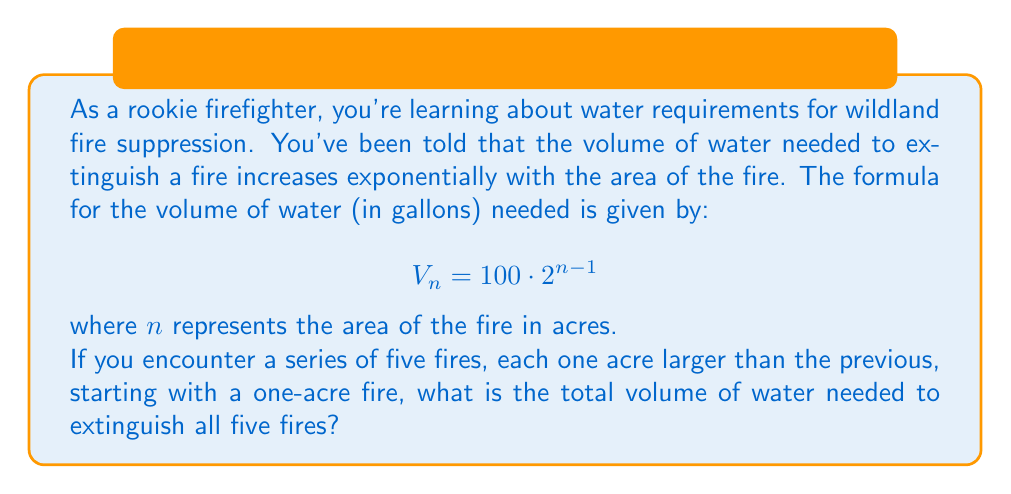Can you answer this question? Let's approach this step-by-step:

1) We need to find the sum of the volumes for fires of 1, 2, 3, 4, and 5 acres.

2) Let's calculate the volume for each fire size:

   For 1 acre: $V_1 = 100 \cdot 2^{1-1} = 100 \cdot 1 = 100$ gallons
   For 2 acres: $V_2 = 100 \cdot 2^{2-1} = 100 \cdot 2 = 200$ gallons
   For 3 acres: $V_3 = 100 \cdot 2^{3-1} = 100 \cdot 4 = 400$ gallons
   For 4 acres: $V_4 = 100 \cdot 2^{4-1} = 100 \cdot 8 = 800$ gallons
   For 5 acres: $V_5 = 100 \cdot 2^{5-1} = 100 \cdot 16 = 1600$ gallons

3) Now, we need to sum these volumes:

   $$\text{Total Volume} = V_1 + V_2 + V_3 + V_4 + V_5$$
   $$= 100 + 200 + 400 + 800 + 1600$$

4) Adding these up:

   $$\text{Total Volume} = 3100 \text{ gallons}$$

This series is actually a geometric series with first term $a = 100$ and common ratio $r = 2$. We could have also solved it using the formula for the sum of a geometric series:

$$S_n = \frac{a(1-r^n)}{1-r} = \frac{100(1-2^5)}{1-2} = 3100$$

This gives us the same result, confirming our step-by-step calculation.
Answer: 3100 gallons 